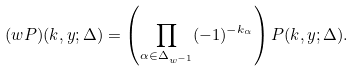<formula> <loc_0><loc_0><loc_500><loc_500>( w P ) ( k , y ; \Delta ) = \left ( \prod _ { \alpha \in \Delta _ { w ^ { - 1 } } } ( - 1 ) ^ { - k _ { \alpha } } \right ) P ( k , y ; \Delta ) .</formula> 